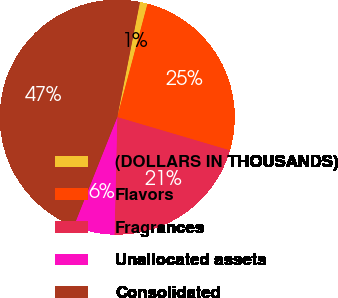<chart> <loc_0><loc_0><loc_500><loc_500><pie_chart><fcel>(DOLLARS IN THOUSANDS)<fcel>Flavors<fcel>Fragrances<fcel>Unallocated assets<fcel>Consolidated<nl><fcel>1.06%<fcel>25.41%<fcel>20.81%<fcel>5.66%<fcel>47.06%<nl></chart> 